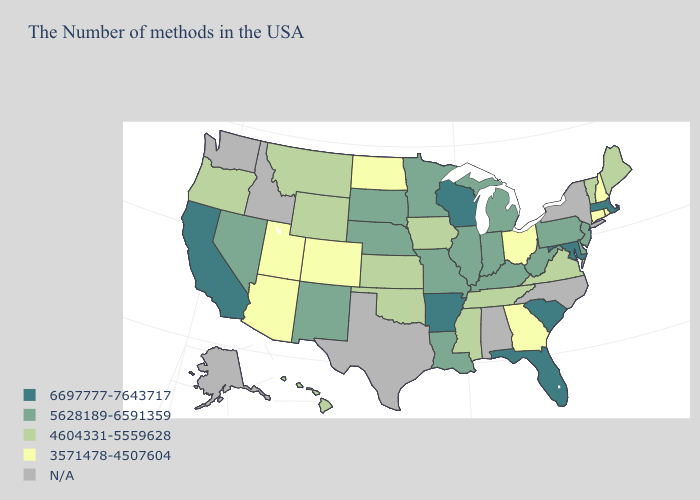What is the value of Arkansas?
Concise answer only. 6697777-7643717. Name the states that have a value in the range 6697777-7643717?
Concise answer only. Massachusetts, Maryland, South Carolina, Florida, Wisconsin, Arkansas, California. Which states hav the highest value in the Northeast?
Write a very short answer. Massachusetts. Which states hav the highest value in the Northeast?
Quick response, please. Massachusetts. Name the states that have a value in the range 5628189-6591359?
Give a very brief answer. New Jersey, Delaware, Pennsylvania, West Virginia, Michigan, Kentucky, Indiana, Illinois, Louisiana, Missouri, Minnesota, Nebraska, South Dakota, New Mexico, Nevada. Among the states that border Kansas , does Missouri have the highest value?
Quick response, please. Yes. What is the lowest value in the West?
Give a very brief answer. 3571478-4507604. Which states hav the highest value in the South?
Concise answer only. Maryland, South Carolina, Florida, Arkansas. What is the value of New Hampshire?
Be succinct. 3571478-4507604. What is the lowest value in the USA?
Quick response, please. 3571478-4507604. Does the first symbol in the legend represent the smallest category?
Short answer required. No. What is the value of Ohio?
Quick response, please. 3571478-4507604. Which states have the lowest value in the USA?
Concise answer only. Rhode Island, New Hampshire, Connecticut, Ohio, Georgia, North Dakota, Colorado, Utah, Arizona. Does Nevada have the lowest value in the West?
Be succinct. No. 